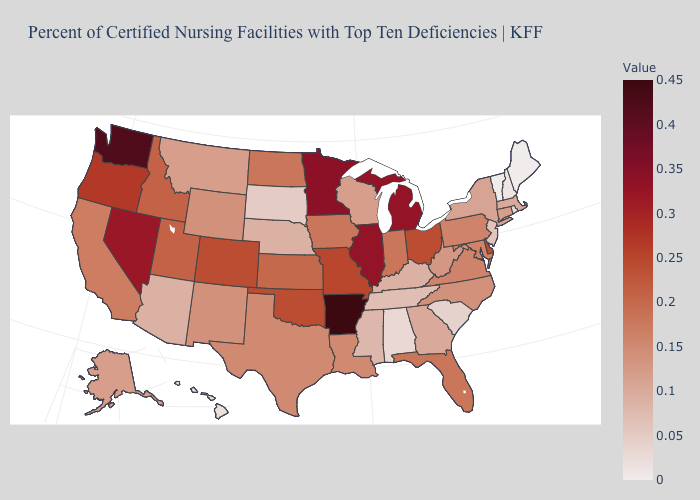Among the states that border Illinois , which have the highest value?
Answer briefly. Missouri. Does Arkansas have the highest value in the USA?
Be succinct. Yes. Does Alabama have the lowest value in the South?
Be succinct. Yes. 